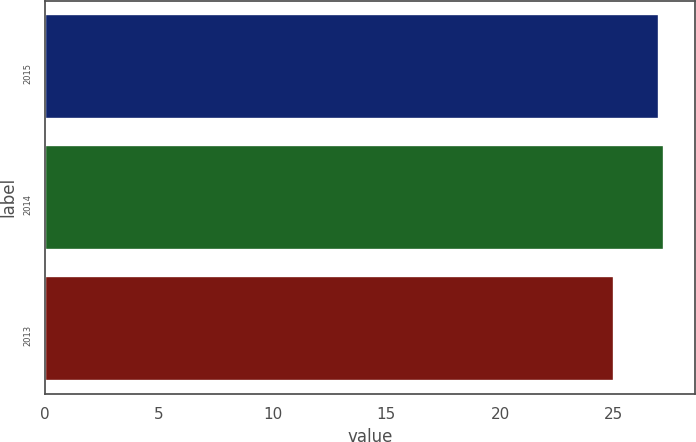Convert chart. <chart><loc_0><loc_0><loc_500><loc_500><bar_chart><fcel>2015<fcel>2014<fcel>2013<nl><fcel>27<fcel>27.2<fcel>25<nl></chart> 